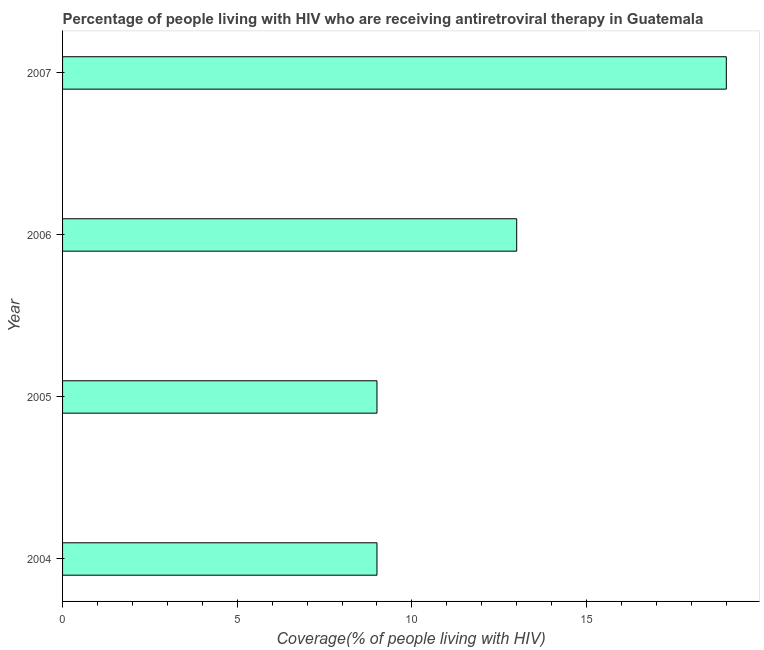Does the graph contain grids?
Your response must be concise. No. What is the title of the graph?
Keep it short and to the point. Percentage of people living with HIV who are receiving antiretroviral therapy in Guatemala. What is the label or title of the X-axis?
Ensure brevity in your answer.  Coverage(% of people living with HIV). Across all years, what is the maximum antiretroviral therapy coverage?
Ensure brevity in your answer.  19. What is the difference between the antiretroviral therapy coverage in 2004 and 2007?
Provide a short and direct response. -10. In how many years, is the antiretroviral therapy coverage greater than 2 %?
Keep it short and to the point. 4. What is the difference between the highest and the second highest antiretroviral therapy coverage?
Your answer should be very brief. 6. What is the difference between the highest and the lowest antiretroviral therapy coverage?
Your response must be concise. 10. Are all the bars in the graph horizontal?
Your answer should be very brief. Yes. How many years are there in the graph?
Offer a terse response. 4. What is the Coverage(% of people living with HIV) of 2004?
Offer a terse response. 9. What is the Coverage(% of people living with HIV) in 2006?
Ensure brevity in your answer.  13. What is the Coverage(% of people living with HIV) in 2007?
Give a very brief answer. 19. What is the difference between the Coverage(% of people living with HIV) in 2004 and 2005?
Make the answer very short. 0. What is the difference between the Coverage(% of people living with HIV) in 2004 and 2007?
Make the answer very short. -10. What is the difference between the Coverage(% of people living with HIV) in 2005 and 2007?
Your response must be concise. -10. What is the difference between the Coverage(% of people living with HIV) in 2006 and 2007?
Make the answer very short. -6. What is the ratio of the Coverage(% of people living with HIV) in 2004 to that in 2005?
Ensure brevity in your answer.  1. What is the ratio of the Coverage(% of people living with HIV) in 2004 to that in 2006?
Provide a succinct answer. 0.69. What is the ratio of the Coverage(% of people living with HIV) in 2004 to that in 2007?
Ensure brevity in your answer.  0.47. What is the ratio of the Coverage(% of people living with HIV) in 2005 to that in 2006?
Provide a succinct answer. 0.69. What is the ratio of the Coverage(% of people living with HIV) in 2005 to that in 2007?
Keep it short and to the point. 0.47. What is the ratio of the Coverage(% of people living with HIV) in 2006 to that in 2007?
Make the answer very short. 0.68. 